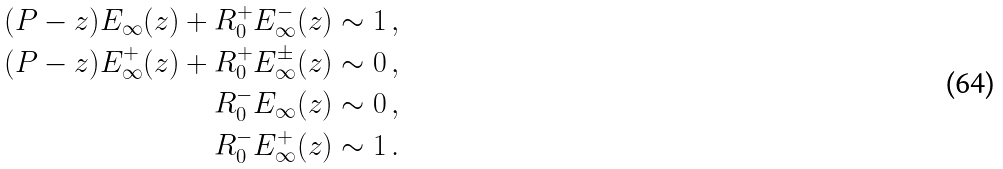Convert formula to latex. <formula><loc_0><loc_0><loc_500><loc_500>( P - z ) E _ { \infty } ( z ) + R _ { 0 } ^ { + } E _ { \infty } ^ { - } ( z ) & \sim 1 \, , \\ ( P - z ) E _ { \infty } ^ { + } ( z ) + R _ { 0 } ^ { + } E _ { \infty } ^ { \pm } ( z ) & \sim 0 \, , \\ R _ { 0 } ^ { - } E _ { \infty } ( z ) & \sim 0 \, , \\ R _ { 0 } ^ { - } E _ { \infty } ^ { + } ( z ) & \sim 1 \, .</formula> 